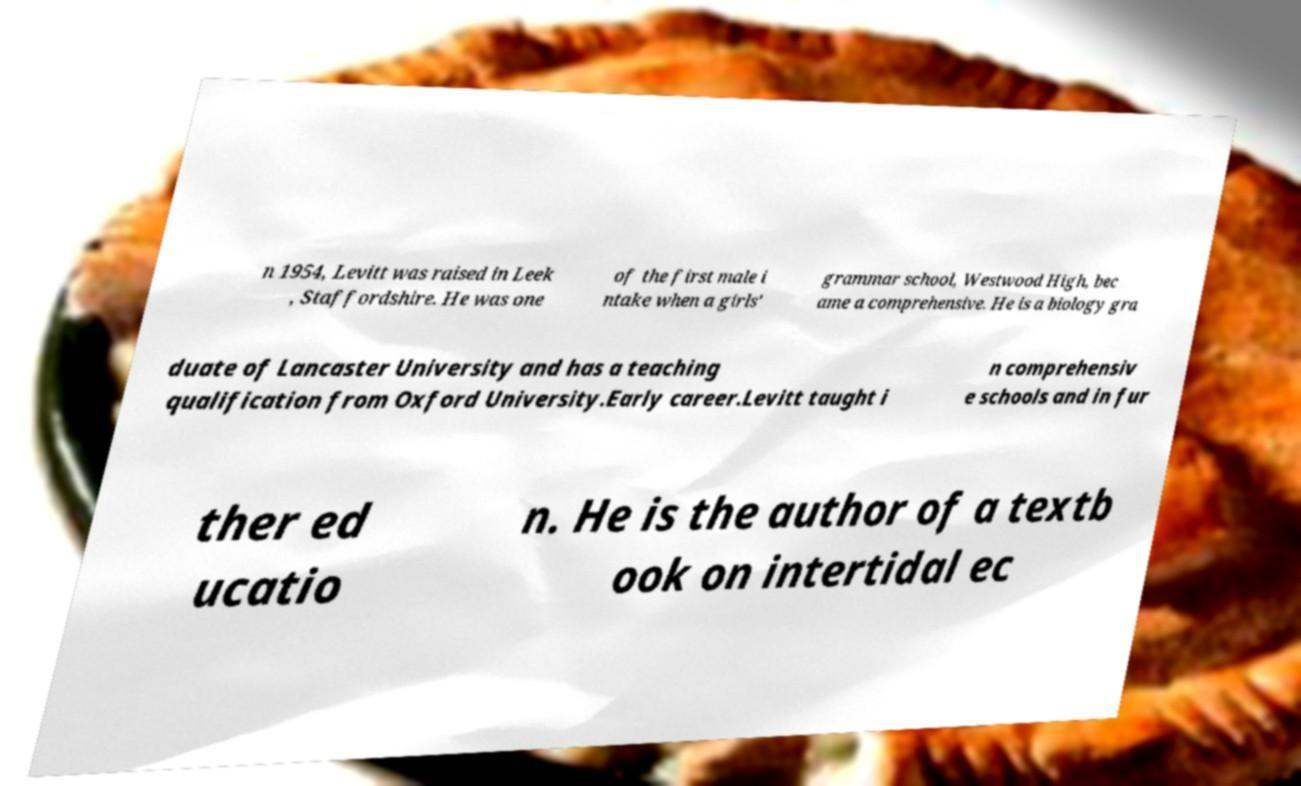Can you read and provide the text displayed in the image?This photo seems to have some interesting text. Can you extract and type it out for me? n 1954, Levitt was raised in Leek , Staffordshire. He was one of the first male i ntake when a girls' grammar school, Westwood High, bec ame a comprehensive. He is a biology gra duate of Lancaster University and has a teaching qualification from Oxford University.Early career.Levitt taught i n comprehensiv e schools and in fur ther ed ucatio n. He is the author of a textb ook on intertidal ec 